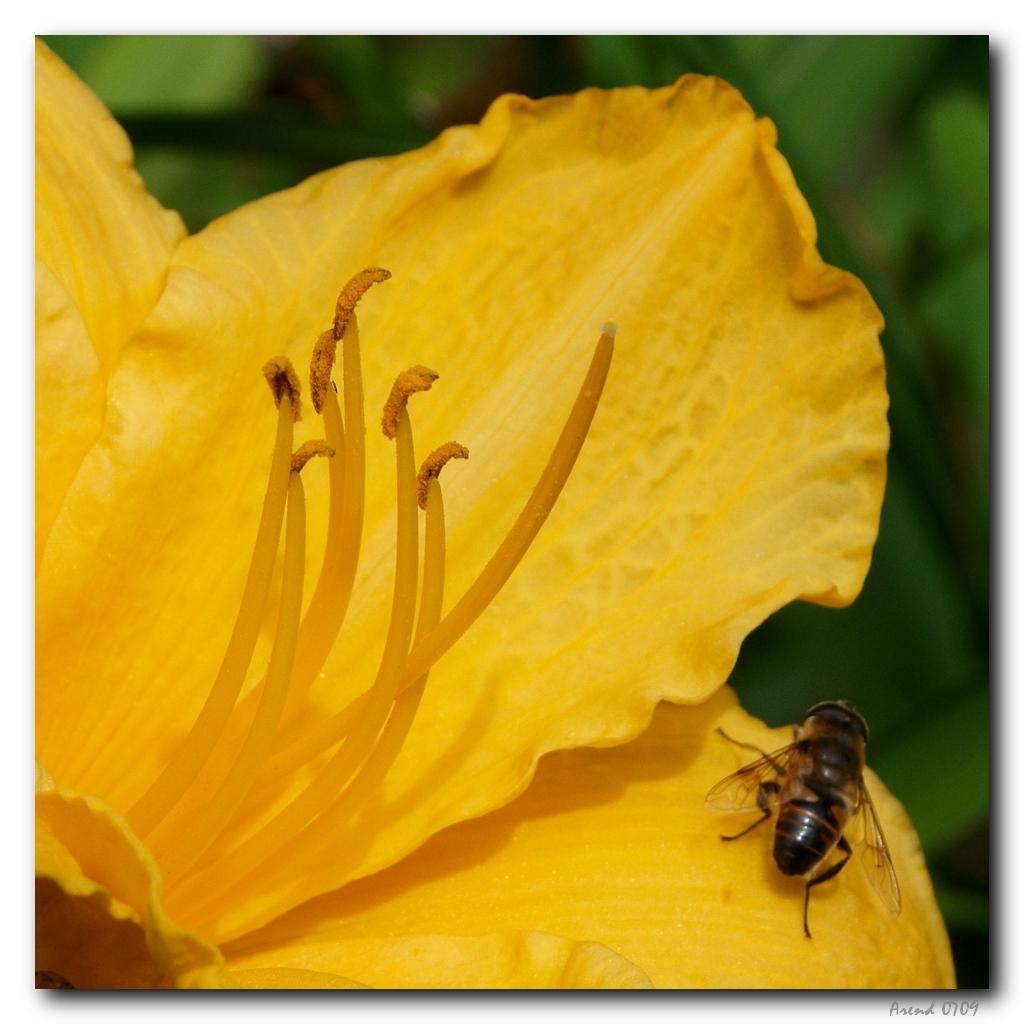How would you summarize this image in a sentence or two? In the front of the image there is a yellow flower and an insect. In the background of the image is blurred. 